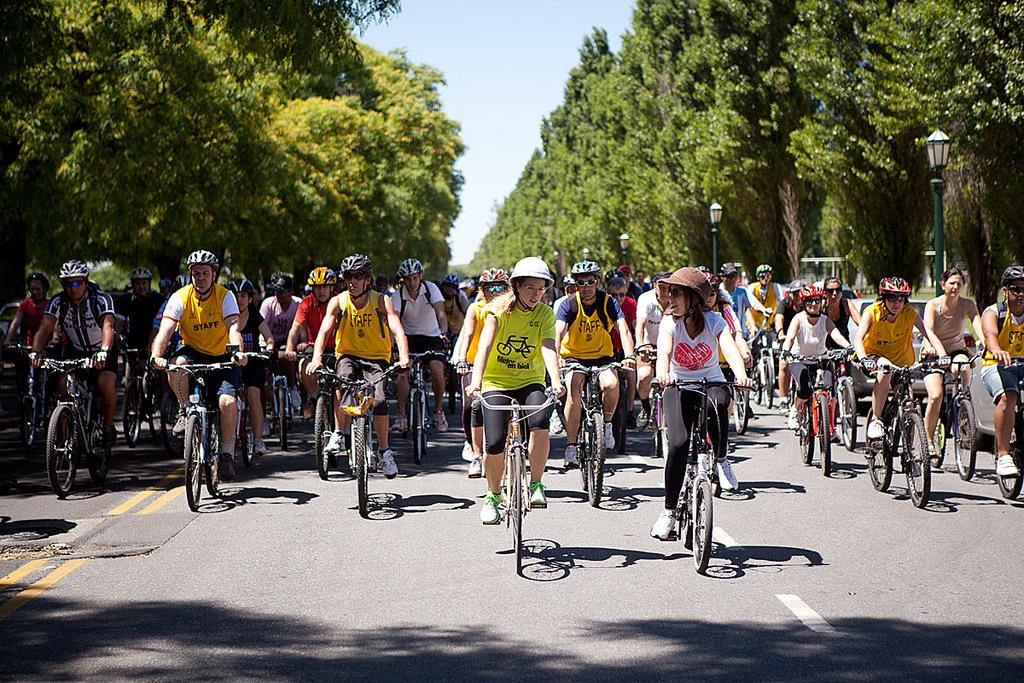How many people are in the image? There is a group of people in the image. What are the people doing in the image? The people are riding bicycles. Where are the people riding their bicycles? The bicycles are on a road. What can be seen in the background of the image? There are trees and street lights visible in the image. What is visible at the top of the image? The sky is visible at the top of the image. What is visible at the bottom of the image? There is a road visible at the bottom of the image. What type of story is being told by the people walking in the image? There are no people walking in the image; the people are riding bicycles. What type of class is being held in the image? There is no class being held in the image; it features a group of people riding bicycles on a road. 